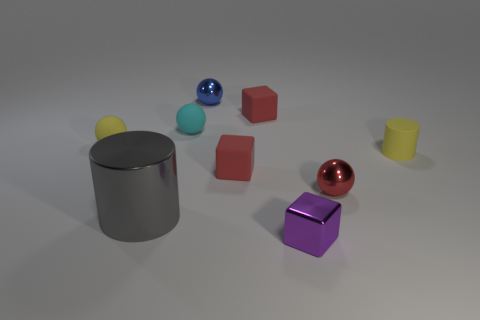What number of other things are made of the same material as the large gray cylinder?
Provide a succinct answer. 3. There is a tiny yellow object right of the tiny blue thing; is it the same shape as the large thing that is behind the small metallic block?
Your answer should be very brief. Yes. Are the small blue object and the yellow ball made of the same material?
Offer a very short reply. No. What is the size of the yellow thing to the right of the small red object right of the metal block that is left of the tiny matte cylinder?
Ensure brevity in your answer.  Small. How many other things are there of the same color as the tiny rubber cylinder?
Provide a short and direct response. 1. What shape is the cyan matte object that is the same size as the purple block?
Make the answer very short. Sphere. What number of small things are either gray shiny cylinders or metallic things?
Offer a very short reply. 3. Are there any small spheres that are behind the tiny red cube in front of the red rubber thing that is behind the small yellow matte ball?
Ensure brevity in your answer.  Yes. Is there a sphere that has the same size as the cyan rubber thing?
Give a very brief answer. Yes. There is a purple object that is the same size as the blue metallic thing; what is it made of?
Give a very brief answer. Metal. 